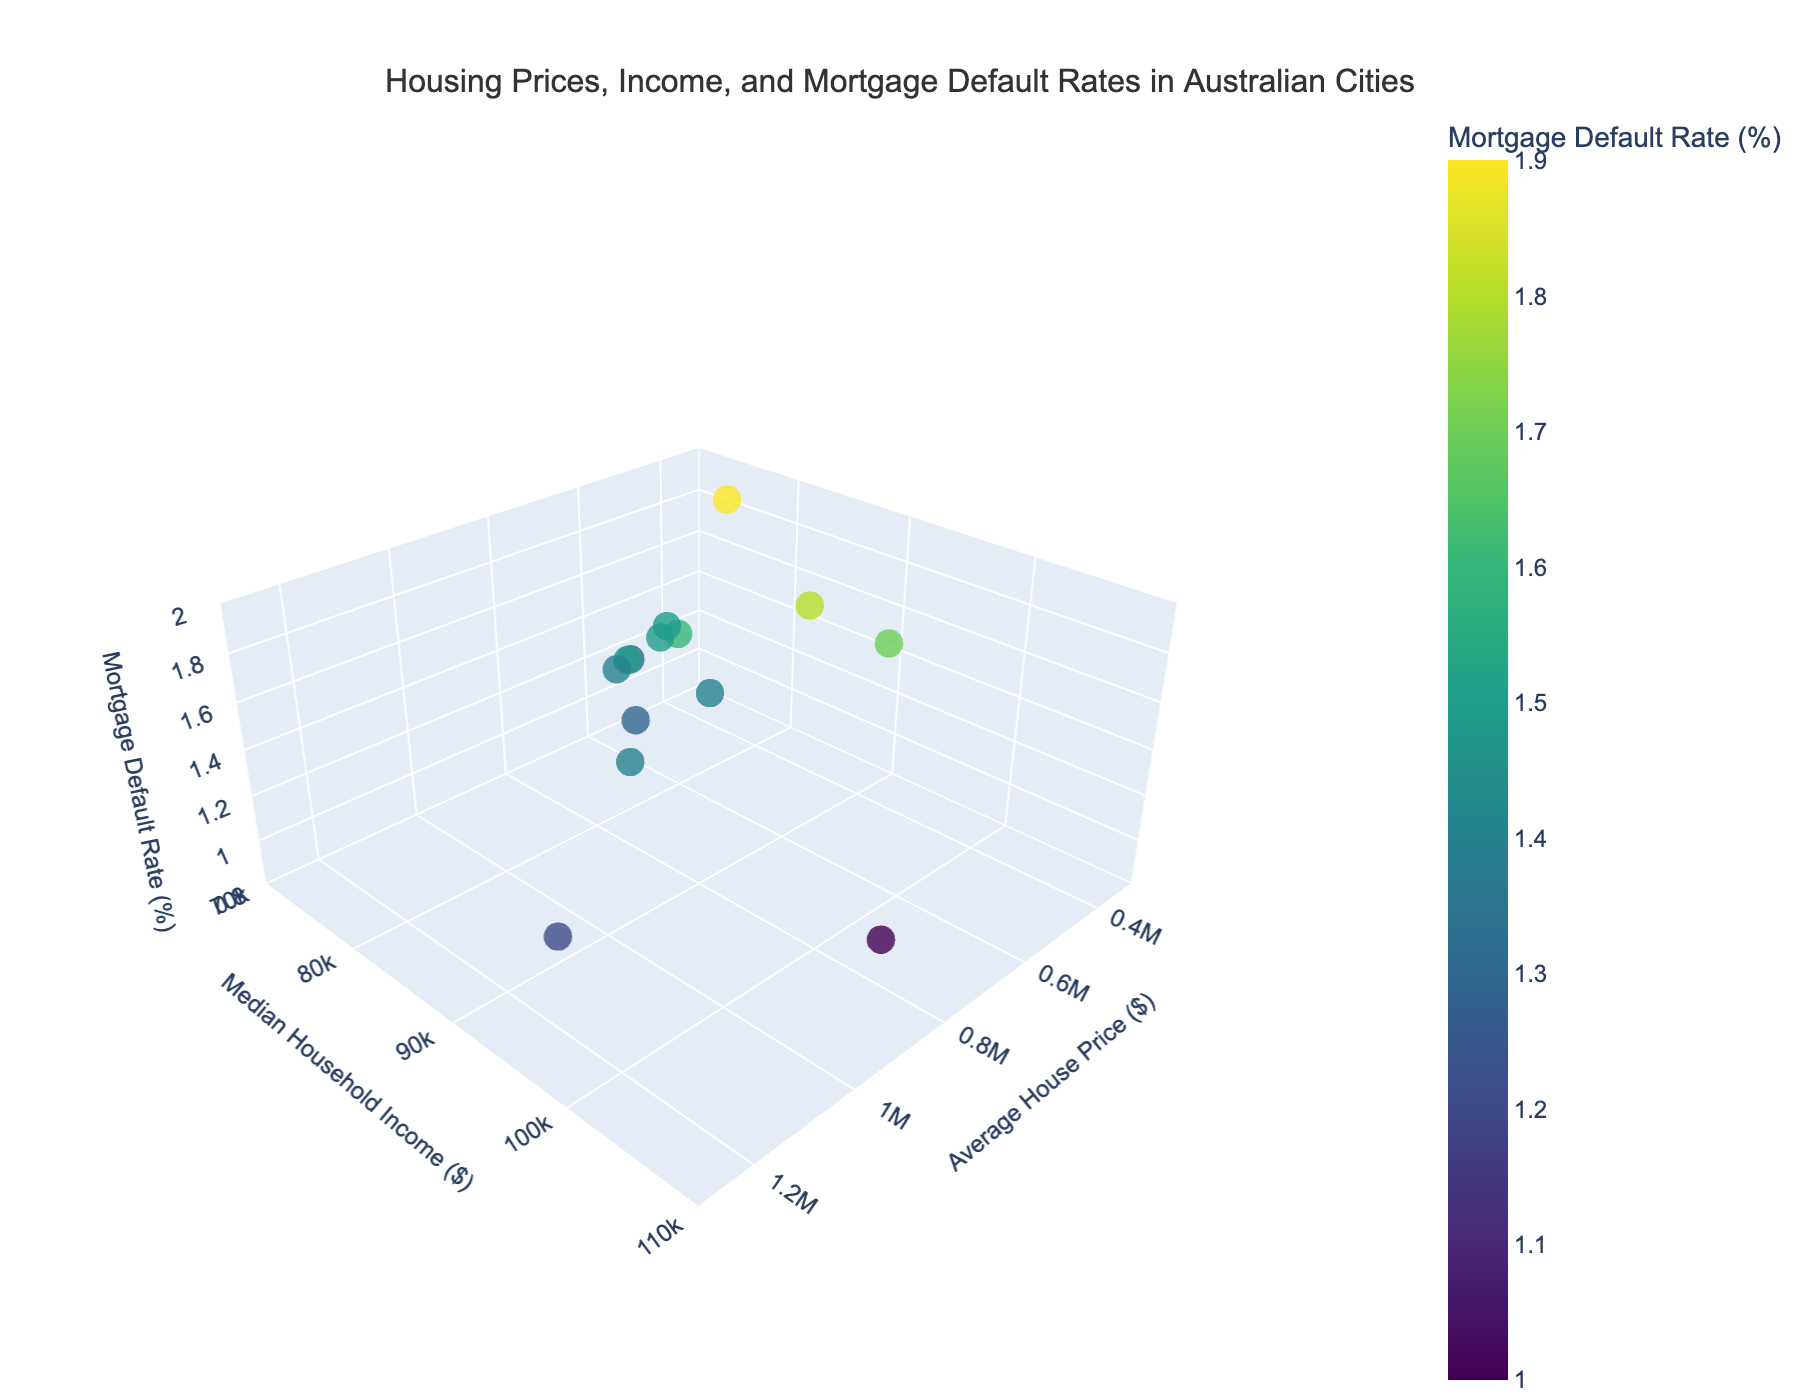What's the title of the plot? The title of the plot is typically displayed at the top of the figure. It is usually descriptive of the data being shown.
Answer: Housing Prices, Income, and Mortgage Default Rates in Australian Cities How many cities are represented in the plot? You can count the total number of markers or data points in the plot. Each marker represents a city.
Answer: 14 Which city has the highest average house price? Locate the city that aligns with the highest value on the x-axis, which represents the average house price.
Answer: Sydney What is the range of the mortgage default rates displayed on the plot? The range can be determined by looking at the z-axis, which represents the mortgage default rate. Note the minimum and maximum values on the axis.
Answer: 0.8% to 2.0% Do cities with higher median household incomes generally have lower mortgage default rates? Compare the positions of cities along the y-axis (median household income) and z-axis (mortgage default rate). Observe if higher incomes correspond to lower default rates.
Answer: Yes Which city has the lowest mortgage default rate and what is it? Identify the city that is positioned at the lowest point on the z-axis.
Answer: Canberra, 1.0% What is the median household income in Perth? Find the position of the marker for Perth and check its alignment on the y-axis, which indicates the median household income.
Answer: $90,000 Comparing Brisbane and Melbourne, which city has a higher mortgage default rate? Find the markers for Brisbane and Melbourne, and compare their positions on the z-axis.
Answer: Brisbane What is the approximate average house price for Darwin? Look for the Darwin marker and check its alignment on the x-axis.
Answer: $500,000 Is there a correlation between average house price and mortgage default rates? Compare the distribution of data points along the x-axis and z-axis. Look for a pattern or trend that indicates correlation.
Answer: Higher house prices generally correspond to lower default rates 